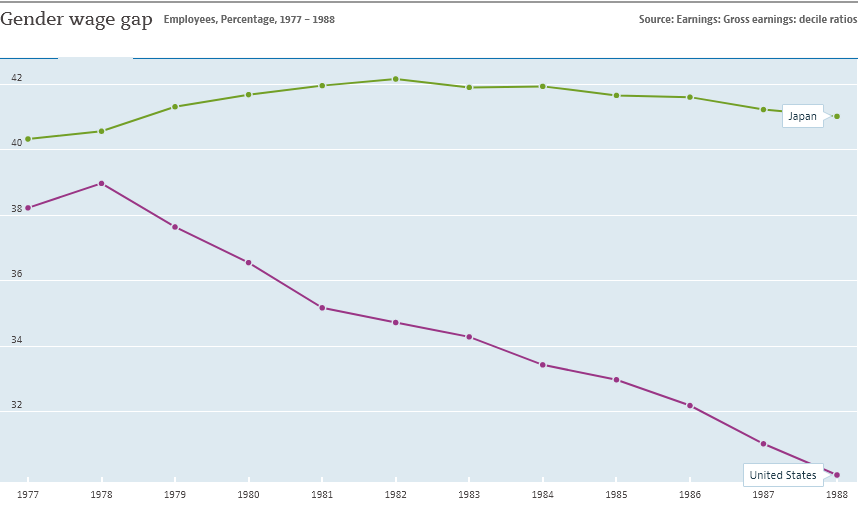Point out several critical features in this image. The gender wage gap is generally greater in Japan than in the United States. According to available data, the gender wage gap was lowest in Japan in the year 1977. 